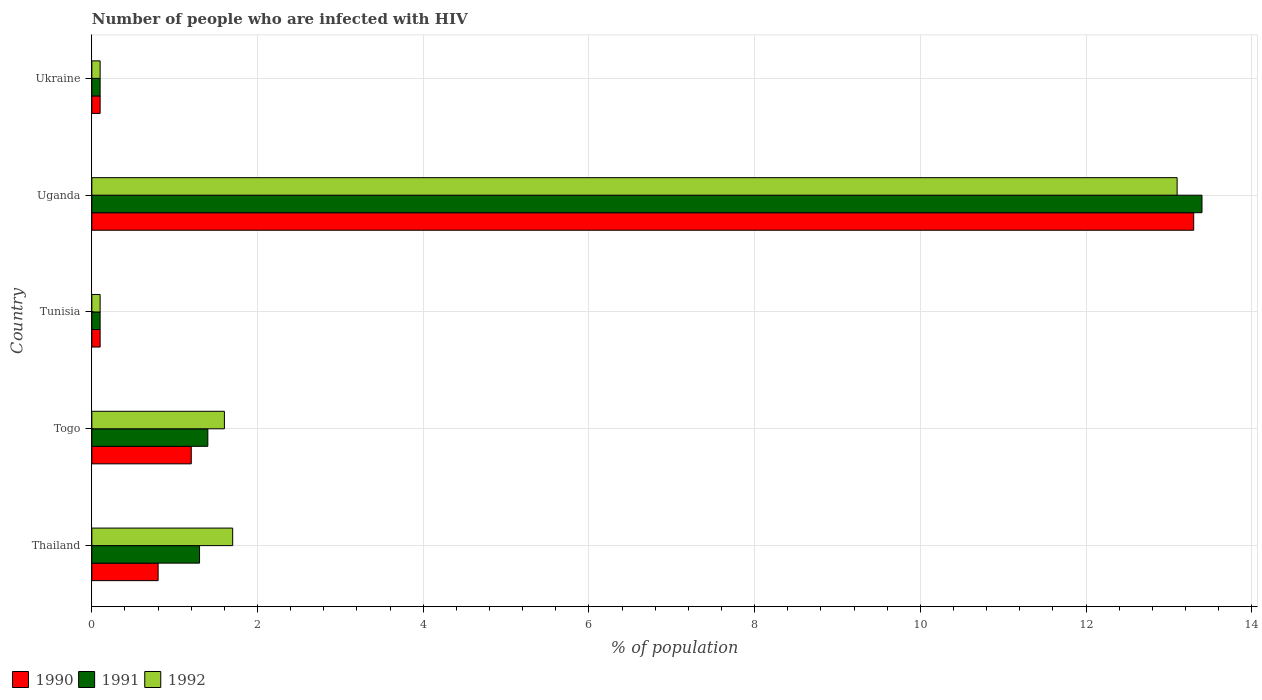How many different coloured bars are there?
Offer a terse response. 3. Are the number of bars per tick equal to the number of legend labels?
Make the answer very short. Yes. Are the number of bars on each tick of the Y-axis equal?
Offer a terse response. Yes. How many bars are there on the 5th tick from the top?
Your response must be concise. 3. What is the label of the 4th group of bars from the top?
Your answer should be compact. Togo. In how many cases, is the number of bars for a given country not equal to the number of legend labels?
Provide a short and direct response. 0. Across all countries, what is the maximum percentage of HIV infected population in in 1992?
Make the answer very short. 13.1. In which country was the percentage of HIV infected population in in 1992 maximum?
Your answer should be very brief. Uganda. In which country was the percentage of HIV infected population in in 1990 minimum?
Ensure brevity in your answer.  Tunisia. What is the total percentage of HIV infected population in in 1992 in the graph?
Offer a terse response. 16.6. What is the difference between the percentage of HIV infected population in in 1991 in Tunisia and that in Uganda?
Provide a short and direct response. -13.3. What is the difference between the percentage of HIV infected population in in 1992 in Uganda and the percentage of HIV infected population in in 1990 in Thailand?
Keep it short and to the point. 12.3. What is the average percentage of HIV infected population in in 1991 per country?
Give a very brief answer. 3.26. What is the difference between the percentage of HIV infected population in in 1991 and percentage of HIV infected population in in 1992 in Thailand?
Ensure brevity in your answer.  -0.4. Is the percentage of HIV infected population in in 1991 in Uganda less than that in Ukraine?
Your answer should be compact. No. Is the difference between the percentage of HIV infected population in in 1991 in Thailand and Togo greater than the difference between the percentage of HIV infected population in in 1992 in Thailand and Togo?
Provide a short and direct response. No. What is the difference between the highest and the second highest percentage of HIV infected population in in 1992?
Your response must be concise. 11.4. What is the difference between the highest and the lowest percentage of HIV infected population in in 1990?
Your answer should be very brief. 13.2. What does the 2nd bar from the top in Ukraine represents?
Offer a very short reply. 1991. How many bars are there?
Provide a succinct answer. 15. How many countries are there in the graph?
Provide a short and direct response. 5. Are the values on the major ticks of X-axis written in scientific E-notation?
Give a very brief answer. No. Does the graph contain grids?
Make the answer very short. Yes. What is the title of the graph?
Ensure brevity in your answer.  Number of people who are infected with HIV. What is the label or title of the X-axis?
Make the answer very short. % of population. What is the % of population in 1990 in Thailand?
Keep it short and to the point. 0.8. What is the % of population in 1991 in Togo?
Give a very brief answer. 1.4. What is the % of population in 1992 in Togo?
Offer a terse response. 1.6. What is the % of population of 1992 in Ukraine?
Your answer should be very brief. 0.1. Across all countries, what is the maximum % of population in 1991?
Provide a succinct answer. 13.4. Across all countries, what is the maximum % of population in 1992?
Ensure brevity in your answer.  13.1. Across all countries, what is the minimum % of population of 1990?
Provide a short and direct response. 0.1. What is the total % of population of 1991 in the graph?
Your answer should be very brief. 16.3. What is the difference between the % of population in 1991 in Thailand and that in Togo?
Ensure brevity in your answer.  -0.1. What is the difference between the % of population in 1992 in Thailand and that in Togo?
Offer a terse response. 0.1. What is the difference between the % of population of 1990 in Thailand and that in Tunisia?
Ensure brevity in your answer.  0.7. What is the difference between the % of population of 1991 in Thailand and that in Tunisia?
Your response must be concise. 1.2. What is the difference between the % of population of 1992 in Thailand and that in Tunisia?
Make the answer very short. 1.6. What is the difference between the % of population in 1990 in Thailand and that in Uganda?
Offer a terse response. -12.5. What is the difference between the % of population of 1992 in Thailand and that in Uganda?
Your answer should be compact. -11.4. What is the difference between the % of population in 1990 in Thailand and that in Ukraine?
Your answer should be compact. 0.7. What is the difference between the % of population in 1991 in Thailand and that in Ukraine?
Offer a terse response. 1.2. What is the difference between the % of population of 1992 in Togo and that in Tunisia?
Provide a short and direct response. 1.5. What is the difference between the % of population in 1991 in Togo and that in Uganda?
Provide a succinct answer. -12. What is the difference between the % of population of 1992 in Togo and that in Uganda?
Provide a succinct answer. -11.5. What is the difference between the % of population of 1991 in Togo and that in Ukraine?
Keep it short and to the point. 1.3. What is the difference between the % of population of 1990 in Tunisia and that in Uganda?
Make the answer very short. -13.2. What is the difference between the % of population in 1992 in Tunisia and that in Uganda?
Provide a succinct answer. -13. What is the difference between the % of population of 1990 in Tunisia and that in Ukraine?
Your answer should be very brief. 0. What is the difference between the % of population of 1991 in Uganda and that in Ukraine?
Ensure brevity in your answer.  13.3. What is the difference between the % of population of 1991 in Thailand and the % of population of 1992 in Togo?
Make the answer very short. -0.3. What is the difference between the % of population of 1990 in Thailand and the % of population of 1991 in Tunisia?
Make the answer very short. 0.7. What is the difference between the % of population in 1991 in Thailand and the % of population in 1992 in Tunisia?
Provide a short and direct response. 1.2. What is the difference between the % of population of 1990 in Thailand and the % of population of 1991 in Uganda?
Offer a very short reply. -12.6. What is the difference between the % of population in 1990 in Thailand and the % of population in 1991 in Ukraine?
Provide a succinct answer. 0.7. What is the difference between the % of population of 1990 in Thailand and the % of population of 1992 in Ukraine?
Keep it short and to the point. 0.7. What is the difference between the % of population in 1991 in Thailand and the % of population in 1992 in Ukraine?
Your answer should be compact. 1.2. What is the difference between the % of population of 1990 in Togo and the % of population of 1991 in Tunisia?
Make the answer very short. 1.1. What is the difference between the % of population in 1990 in Togo and the % of population in 1992 in Tunisia?
Provide a succinct answer. 1.1. What is the difference between the % of population of 1991 in Togo and the % of population of 1992 in Tunisia?
Make the answer very short. 1.3. What is the difference between the % of population in 1990 in Togo and the % of population in 1991 in Uganda?
Your response must be concise. -12.2. What is the difference between the % of population in 1991 in Togo and the % of population in 1992 in Uganda?
Your response must be concise. -11.7. What is the difference between the % of population of 1990 in Togo and the % of population of 1992 in Ukraine?
Provide a short and direct response. 1.1. What is the difference between the % of population in 1990 in Tunisia and the % of population in 1991 in Uganda?
Make the answer very short. -13.3. What is the difference between the % of population in 1991 in Tunisia and the % of population in 1992 in Uganda?
Offer a very short reply. -13. What is the difference between the % of population of 1990 in Tunisia and the % of population of 1991 in Ukraine?
Keep it short and to the point. 0. What is the difference between the % of population of 1990 in Tunisia and the % of population of 1992 in Ukraine?
Your response must be concise. 0. What is the difference between the % of population of 1990 in Uganda and the % of population of 1991 in Ukraine?
Make the answer very short. 13.2. What is the average % of population of 1990 per country?
Provide a succinct answer. 3.1. What is the average % of population in 1991 per country?
Provide a succinct answer. 3.26. What is the average % of population in 1992 per country?
Your response must be concise. 3.32. What is the difference between the % of population in 1990 and % of population in 1992 in Thailand?
Your answer should be compact. -0.9. What is the difference between the % of population of 1990 and % of population of 1991 in Togo?
Keep it short and to the point. -0.2. What is the difference between the % of population in 1990 and % of population in 1992 in Togo?
Your response must be concise. -0.4. What is the difference between the % of population in 1990 and % of population in 1991 in Tunisia?
Your answer should be compact. 0. What is the difference between the % of population in 1991 and % of population in 1992 in Tunisia?
Provide a short and direct response. 0. What is the difference between the % of population of 1991 and % of population of 1992 in Uganda?
Offer a terse response. 0.3. What is the ratio of the % of population of 1991 in Thailand to that in Togo?
Provide a short and direct response. 0.93. What is the ratio of the % of population in 1992 in Thailand to that in Togo?
Provide a short and direct response. 1.06. What is the ratio of the % of population of 1992 in Thailand to that in Tunisia?
Offer a terse response. 17. What is the ratio of the % of population of 1990 in Thailand to that in Uganda?
Your answer should be very brief. 0.06. What is the ratio of the % of population of 1991 in Thailand to that in Uganda?
Make the answer very short. 0.1. What is the ratio of the % of population in 1992 in Thailand to that in Uganda?
Offer a terse response. 0.13. What is the ratio of the % of population of 1991 in Thailand to that in Ukraine?
Your answer should be very brief. 13. What is the ratio of the % of population in 1990 in Togo to that in Tunisia?
Provide a succinct answer. 12. What is the ratio of the % of population in 1991 in Togo to that in Tunisia?
Your response must be concise. 14. What is the ratio of the % of population of 1992 in Togo to that in Tunisia?
Offer a terse response. 16. What is the ratio of the % of population in 1990 in Togo to that in Uganda?
Make the answer very short. 0.09. What is the ratio of the % of population of 1991 in Togo to that in Uganda?
Offer a terse response. 0.1. What is the ratio of the % of population of 1992 in Togo to that in Uganda?
Your answer should be very brief. 0.12. What is the ratio of the % of population in 1990 in Togo to that in Ukraine?
Offer a very short reply. 12. What is the ratio of the % of population of 1991 in Togo to that in Ukraine?
Give a very brief answer. 14. What is the ratio of the % of population in 1990 in Tunisia to that in Uganda?
Provide a short and direct response. 0.01. What is the ratio of the % of population in 1991 in Tunisia to that in Uganda?
Your answer should be compact. 0.01. What is the ratio of the % of population in 1992 in Tunisia to that in Uganda?
Give a very brief answer. 0.01. What is the ratio of the % of population in 1990 in Tunisia to that in Ukraine?
Offer a very short reply. 1. What is the ratio of the % of population of 1992 in Tunisia to that in Ukraine?
Keep it short and to the point. 1. What is the ratio of the % of population of 1990 in Uganda to that in Ukraine?
Offer a terse response. 133. What is the ratio of the % of population of 1991 in Uganda to that in Ukraine?
Provide a succinct answer. 134. What is the ratio of the % of population in 1992 in Uganda to that in Ukraine?
Provide a succinct answer. 131. What is the difference between the highest and the second highest % of population in 1990?
Provide a succinct answer. 12.1. What is the difference between the highest and the second highest % of population of 1991?
Your answer should be very brief. 12. What is the difference between the highest and the lowest % of population in 1992?
Your response must be concise. 13. 